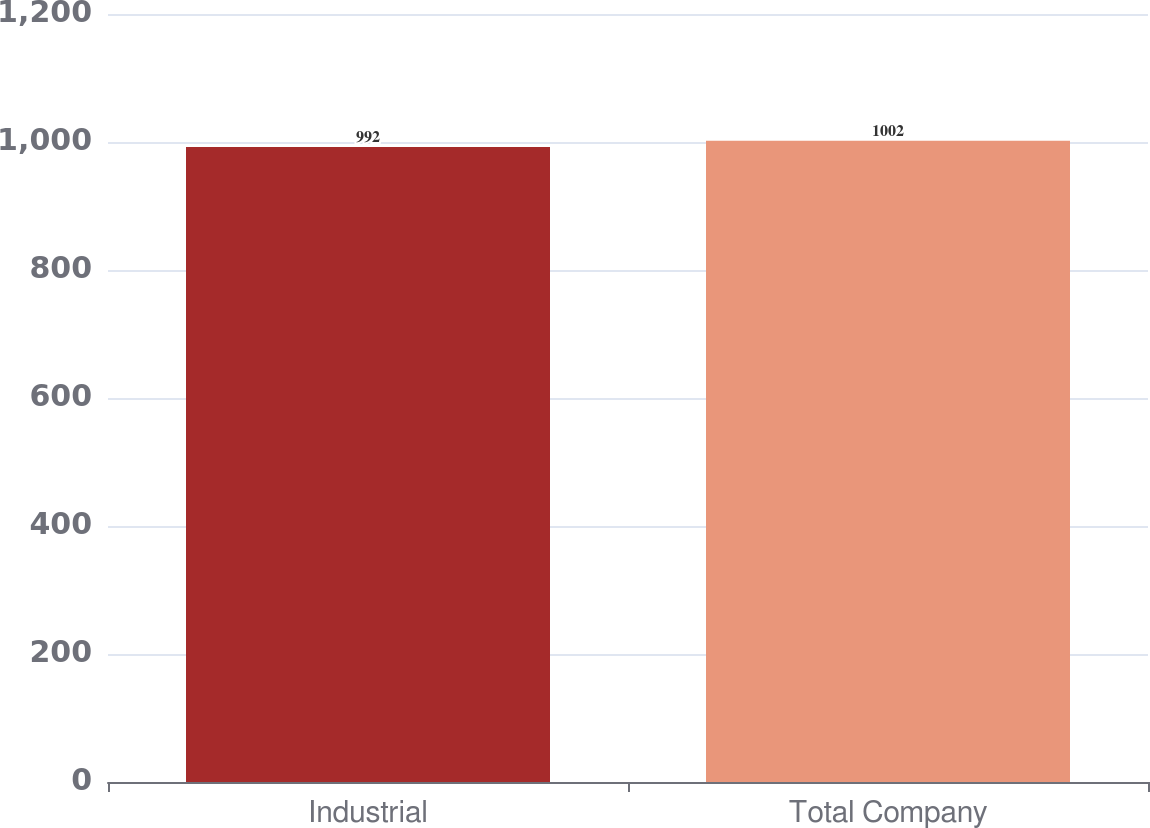Convert chart. <chart><loc_0><loc_0><loc_500><loc_500><bar_chart><fcel>Industrial<fcel>Total Company<nl><fcel>992<fcel>1002<nl></chart> 